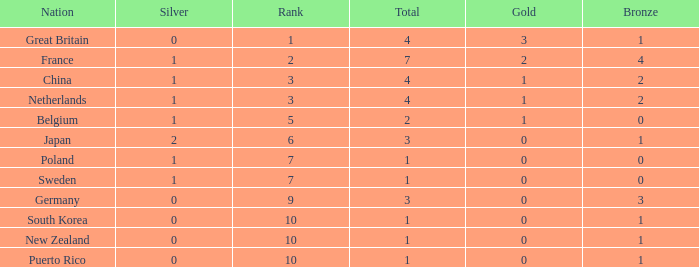What is the smallest number of gold where the total is less than 3 and the silver count is 2? None. 